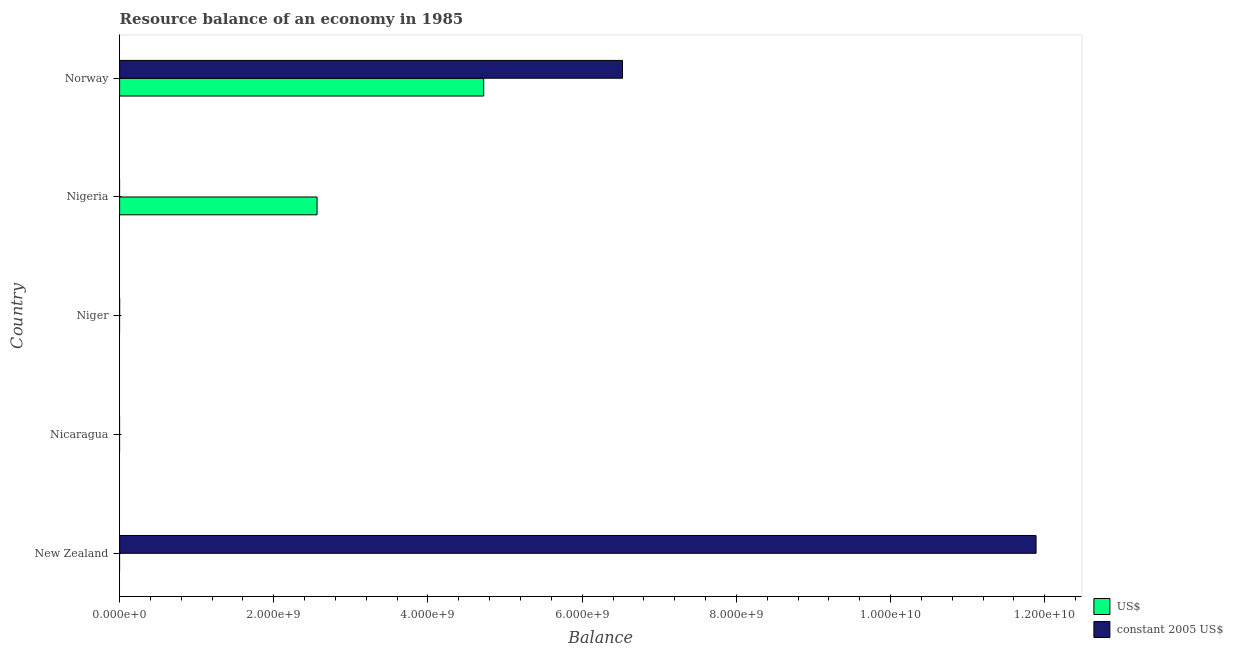What is the label of the 4th group of bars from the top?
Your answer should be very brief. Nicaragua. Across all countries, what is the maximum resource balance in us$?
Your answer should be very brief. 4.72e+09. In which country was the resource balance in constant us$ maximum?
Keep it short and to the point. New Zealand. What is the total resource balance in us$ in the graph?
Ensure brevity in your answer.  7.28e+09. What is the difference between the resource balance in constant us$ in New Zealand and that in Norway?
Your answer should be very brief. 5.36e+09. What is the difference between the resource balance in constant us$ in Norway and the resource balance in us$ in New Zealand?
Provide a succinct answer. 6.52e+09. What is the average resource balance in constant us$ per country?
Make the answer very short. 3.68e+09. What is the difference between the resource balance in us$ and resource balance in constant us$ in Norway?
Provide a succinct answer. -1.80e+09. What is the difference between the highest and the lowest resource balance in constant us$?
Your answer should be very brief. 1.19e+1. How many bars are there?
Your answer should be compact. 4. Are all the bars in the graph horizontal?
Your answer should be compact. Yes. What is the difference between two consecutive major ticks on the X-axis?
Your answer should be very brief. 2.00e+09. Are the values on the major ticks of X-axis written in scientific E-notation?
Make the answer very short. Yes. Does the graph contain any zero values?
Your answer should be very brief. Yes. Where does the legend appear in the graph?
Your answer should be very brief. Bottom right. How are the legend labels stacked?
Your response must be concise. Vertical. What is the title of the graph?
Offer a terse response. Resource balance of an economy in 1985. Does "% of gross capital formation" appear as one of the legend labels in the graph?
Give a very brief answer. No. What is the label or title of the X-axis?
Make the answer very short. Balance. What is the label or title of the Y-axis?
Offer a terse response. Country. What is the Balance in US$ in New Zealand?
Offer a terse response. 0. What is the Balance in constant 2005 US$ in New Zealand?
Your answer should be compact. 1.19e+1. What is the Balance of US$ in Nicaragua?
Keep it short and to the point. 0. What is the Balance of US$ in Niger?
Offer a very short reply. 0. What is the Balance in constant 2005 US$ in Niger?
Your answer should be very brief. 0. What is the Balance in US$ in Nigeria?
Keep it short and to the point. 2.56e+09. What is the Balance of constant 2005 US$ in Nigeria?
Your answer should be compact. 0. What is the Balance of US$ in Norway?
Your response must be concise. 4.72e+09. What is the Balance of constant 2005 US$ in Norway?
Your answer should be compact. 6.52e+09. Across all countries, what is the maximum Balance in US$?
Make the answer very short. 4.72e+09. Across all countries, what is the maximum Balance of constant 2005 US$?
Your response must be concise. 1.19e+1. Across all countries, what is the minimum Balance in constant 2005 US$?
Provide a succinct answer. 0. What is the total Balance of US$ in the graph?
Offer a terse response. 7.28e+09. What is the total Balance in constant 2005 US$ in the graph?
Provide a short and direct response. 1.84e+1. What is the difference between the Balance of constant 2005 US$ in New Zealand and that in Norway?
Give a very brief answer. 5.36e+09. What is the difference between the Balance in US$ in Nigeria and that in Norway?
Provide a succinct answer. -2.16e+09. What is the difference between the Balance of US$ in Nigeria and the Balance of constant 2005 US$ in Norway?
Offer a terse response. -3.96e+09. What is the average Balance in US$ per country?
Your answer should be very brief. 1.46e+09. What is the average Balance in constant 2005 US$ per country?
Offer a terse response. 3.68e+09. What is the difference between the Balance in US$ and Balance in constant 2005 US$ in Norway?
Provide a succinct answer. -1.80e+09. What is the ratio of the Balance of constant 2005 US$ in New Zealand to that in Norway?
Provide a succinct answer. 1.82. What is the ratio of the Balance of US$ in Nigeria to that in Norway?
Offer a terse response. 0.54. What is the difference between the highest and the lowest Balance of US$?
Provide a short and direct response. 4.72e+09. What is the difference between the highest and the lowest Balance in constant 2005 US$?
Ensure brevity in your answer.  1.19e+1. 